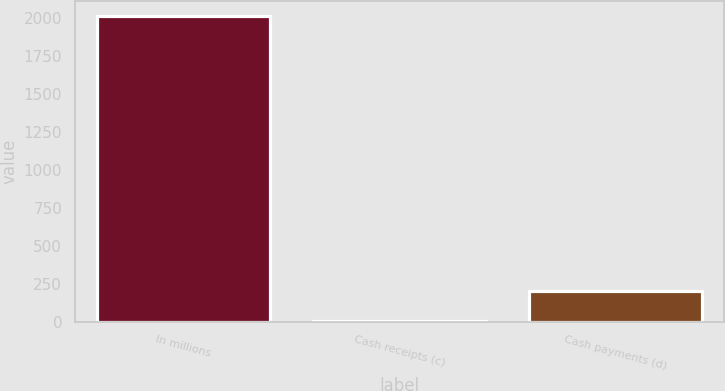Convert chart. <chart><loc_0><loc_0><loc_500><loc_500><bar_chart><fcel>In millions<fcel>Cash receipts (c)<fcel>Cash payments (d)<nl><fcel>2010<fcel>3<fcel>203.7<nl></chart> 